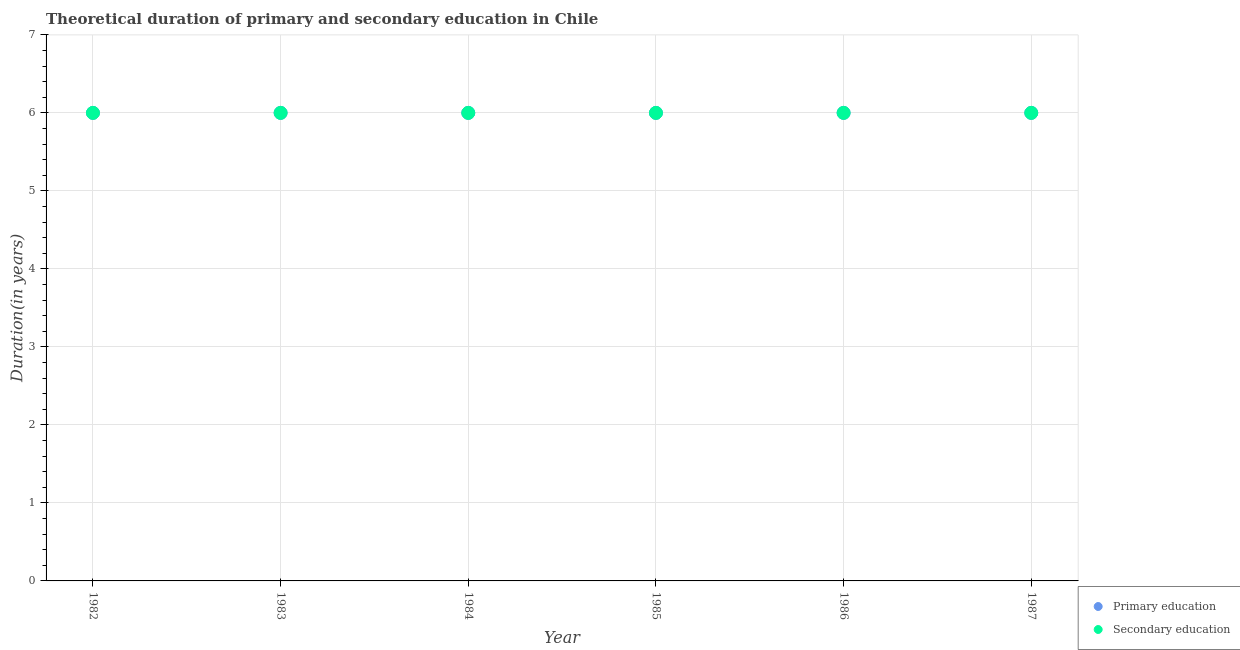How many different coloured dotlines are there?
Your answer should be compact. 2. In which year was the duration of primary education maximum?
Make the answer very short. 1982. In which year was the duration of secondary education minimum?
Your answer should be compact. 1982. What is the total duration of primary education in the graph?
Offer a very short reply. 36. What is the difference between the duration of secondary education in 1985 and that in 1986?
Offer a very short reply. 0. What is the difference between the duration of primary education in 1985 and the duration of secondary education in 1986?
Give a very brief answer. 0. In how many years, is the duration of primary education greater than the average duration of primary education taken over all years?
Ensure brevity in your answer.  0. Is the sum of the duration of primary education in 1983 and 1986 greater than the maximum duration of secondary education across all years?
Your answer should be compact. Yes. Does the duration of primary education monotonically increase over the years?
Give a very brief answer. No. Is the duration of secondary education strictly greater than the duration of primary education over the years?
Keep it short and to the point. No. Is the duration of secondary education strictly less than the duration of primary education over the years?
Provide a short and direct response. No. How many years are there in the graph?
Keep it short and to the point. 6. What is the difference between two consecutive major ticks on the Y-axis?
Provide a short and direct response. 1. Are the values on the major ticks of Y-axis written in scientific E-notation?
Your answer should be very brief. No. How are the legend labels stacked?
Your response must be concise. Vertical. What is the title of the graph?
Provide a succinct answer. Theoretical duration of primary and secondary education in Chile. What is the label or title of the Y-axis?
Keep it short and to the point. Duration(in years). What is the Duration(in years) in Primary education in 1982?
Provide a succinct answer. 6. What is the Duration(in years) of Secondary education in 1982?
Keep it short and to the point. 6. What is the Duration(in years) of Secondary education in 1983?
Provide a short and direct response. 6. What is the Duration(in years) in Secondary education in 1984?
Make the answer very short. 6. What is the Duration(in years) in Secondary education in 1985?
Your answer should be compact. 6. What is the Duration(in years) of Primary education in 1986?
Ensure brevity in your answer.  6. What is the Duration(in years) in Secondary education in 1986?
Offer a terse response. 6. Across all years, what is the maximum Duration(in years) of Secondary education?
Offer a very short reply. 6. Across all years, what is the minimum Duration(in years) in Primary education?
Offer a terse response. 6. Across all years, what is the minimum Duration(in years) in Secondary education?
Make the answer very short. 6. What is the difference between the Duration(in years) in Secondary education in 1982 and that in 1984?
Offer a very short reply. 0. What is the difference between the Duration(in years) in Primary education in 1982 and that in 1985?
Offer a terse response. 0. What is the difference between the Duration(in years) in Secondary education in 1982 and that in 1986?
Provide a short and direct response. 0. What is the difference between the Duration(in years) in Secondary education in 1983 and that in 1984?
Provide a short and direct response. 0. What is the difference between the Duration(in years) of Secondary education in 1983 and that in 1986?
Provide a succinct answer. 0. What is the difference between the Duration(in years) of Primary education in 1984 and that in 1985?
Give a very brief answer. 0. What is the difference between the Duration(in years) of Secondary education in 1984 and that in 1985?
Provide a succinct answer. 0. What is the difference between the Duration(in years) of Secondary education in 1985 and that in 1986?
Make the answer very short. 0. What is the difference between the Duration(in years) of Secondary education in 1985 and that in 1987?
Make the answer very short. 0. What is the difference between the Duration(in years) in Primary education in 1982 and the Duration(in years) in Secondary education in 1983?
Provide a succinct answer. 0. What is the difference between the Duration(in years) in Primary education in 1982 and the Duration(in years) in Secondary education in 1985?
Offer a terse response. 0. What is the difference between the Duration(in years) in Primary education in 1982 and the Duration(in years) in Secondary education in 1986?
Give a very brief answer. 0. What is the difference between the Duration(in years) of Primary education in 1983 and the Duration(in years) of Secondary education in 1985?
Provide a short and direct response. 0. What is the difference between the Duration(in years) in Primary education in 1983 and the Duration(in years) in Secondary education in 1986?
Offer a terse response. 0. What is the difference between the Duration(in years) of Primary education in 1983 and the Duration(in years) of Secondary education in 1987?
Your answer should be compact. 0. What is the difference between the Duration(in years) of Primary education in 1984 and the Duration(in years) of Secondary education in 1985?
Provide a succinct answer. 0. What is the difference between the Duration(in years) in Primary education in 1984 and the Duration(in years) in Secondary education in 1987?
Provide a succinct answer. 0. What is the difference between the Duration(in years) of Primary education in 1985 and the Duration(in years) of Secondary education in 1987?
Offer a very short reply. 0. What is the difference between the Duration(in years) in Primary education in 1986 and the Duration(in years) in Secondary education in 1987?
Keep it short and to the point. 0. What is the average Duration(in years) of Primary education per year?
Keep it short and to the point. 6. In the year 1983, what is the difference between the Duration(in years) in Primary education and Duration(in years) in Secondary education?
Make the answer very short. 0. In the year 1984, what is the difference between the Duration(in years) of Primary education and Duration(in years) of Secondary education?
Offer a terse response. 0. In the year 1985, what is the difference between the Duration(in years) in Primary education and Duration(in years) in Secondary education?
Your response must be concise. 0. What is the ratio of the Duration(in years) in Primary education in 1982 to that in 1984?
Your response must be concise. 1. What is the ratio of the Duration(in years) of Secondary education in 1982 to that in 1985?
Keep it short and to the point. 1. What is the ratio of the Duration(in years) of Secondary education in 1982 to that in 1986?
Provide a short and direct response. 1. What is the ratio of the Duration(in years) of Primary education in 1982 to that in 1987?
Give a very brief answer. 1. What is the ratio of the Duration(in years) in Secondary education in 1983 to that in 1984?
Ensure brevity in your answer.  1. What is the ratio of the Duration(in years) of Secondary education in 1984 to that in 1985?
Keep it short and to the point. 1. What is the ratio of the Duration(in years) of Secondary education in 1984 to that in 1987?
Your answer should be compact. 1. What is the ratio of the Duration(in years) in Primary education in 1985 to that in 1986?
Make the answer very short. 1. What is the ratio of the Duration(in years) in Primary education in 1986 to that in 1987?
Give a very brief answer. 1. What is the ratio of the Duration(in years) in Secondary education in 1986 to that in 1987?
Offer a terse response. 1. What is the difference between the highest and the second highest Duration(in years) of Primary education?
Offer a very short reply. 0. What is the difference between the highest and the lowest Duration(in years) of Primary education?
Give a very brief answer. 0. 